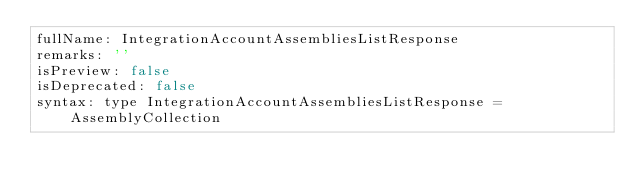<code> <loc_0><loc_0><loc_500><loc_500><_YAML_>fullName: IntegrationAccountAssembliesListResponse
remarks: ''
isPreview: false
isDeprecated: false
syntax: type IntegrationAccountAssembliesListResponse = AssemblyCollection
</code> 